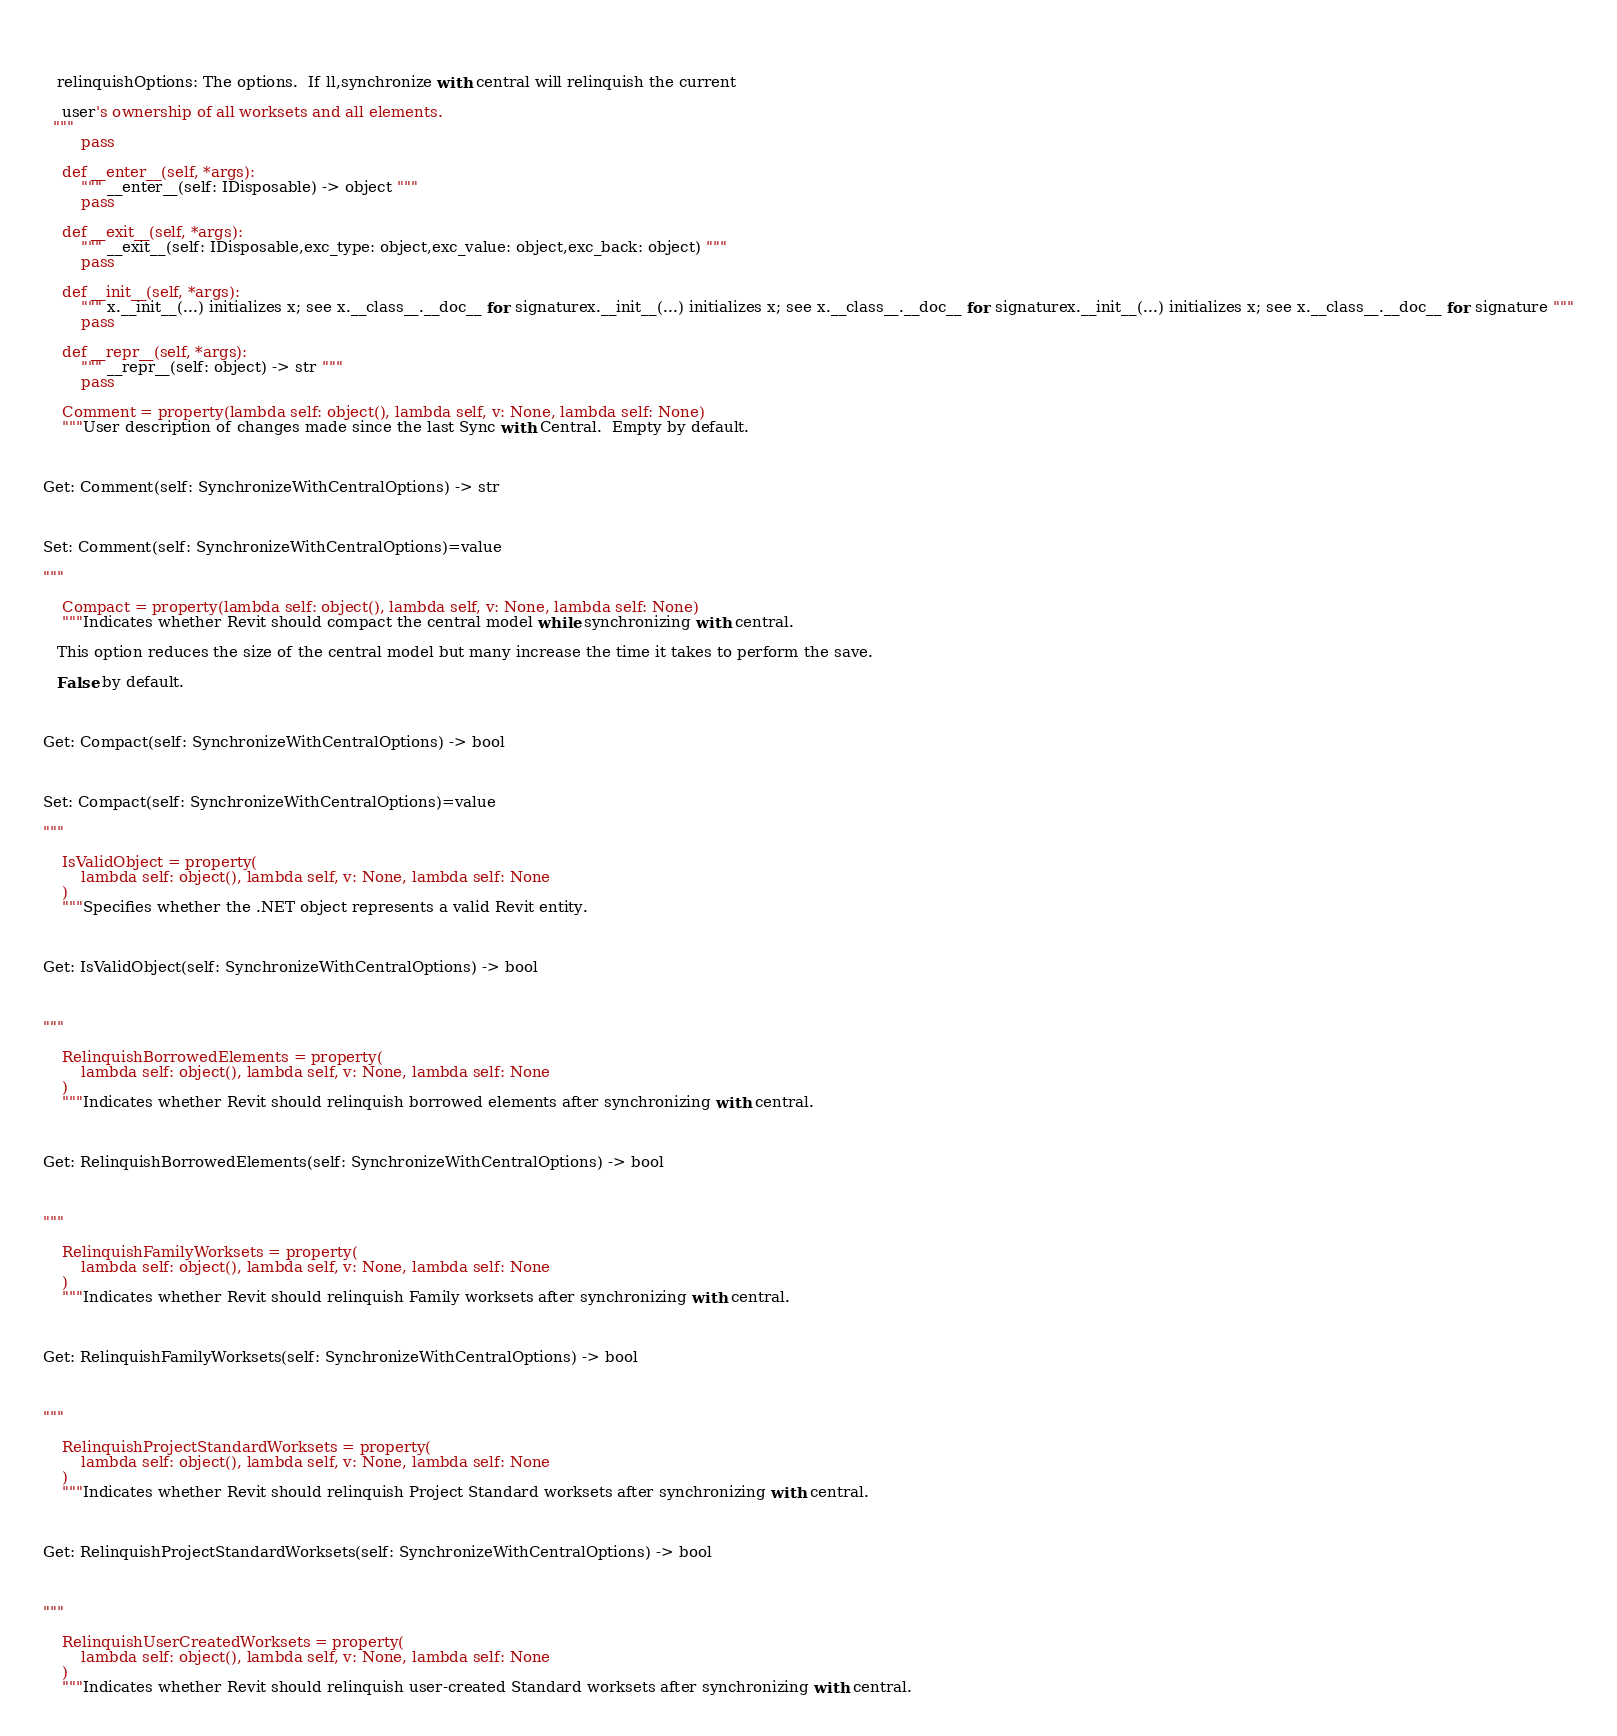Convert code to text. <code><loc_0><loc_0><loc_500><loc_500><_Python_>
  

   relinquishOptions: The options.  If ll,synchronize with central will relinquish the current 

    user's ownership of all worksets and all elements.
  """
        pass

    def __enter__(self, *args):
        """ __enter__(self: IDisposable) -> object """
        pass

    def __exit__(self, *args):
        """ __exit__(self: IDisposable,exc_type: object,exc_value: object,exc_back: object) """
        pass

    def __init__(self, *args):
        """ x.__init__(...) initializes x; see x.__class__.__doc__ for signaturex.__init__(...) initializes x; see x.__class__.__doc__ for signaturex.__init__(...) initializes x; see x.__class__.__doc__ for signature """
        pass

    def __repr__(self, *args):
        """ __repr__(self: object) -> str """
        pass

    Comment = property(lambda self: object(), lambda self, v: None, lambda self: None)
    """User description of changes made since the last Sync with Central.  Empty by default.



Get: Comment(self: SynchronizeWithCentralOptions) -> str



Set: Comment(self: SynchronizeWithCentralOptions)=value

"""

    Compact = property(lambda self: object(), lambda self, v: None, lambda self: None)
    """Indicates whether Revit should compact the central model while synchronizing with central.

   This option reduces the size of the central model but many increase the time it takes to perform the save.

   False by default.



Get: Compact(self: SynchronizeWithCentralOptions) -> bool



Set: Compact(self: SynchronizeWithCentralOptions)=value

"""

    IsValidObject = property(
        lambda self: object(), lambda self, v: None, lambda self: None
    )
    """Specifies whether the .NET object represents a valid Revit entity.



Get: IsValidObject(self: SynchronizeWithCentralOptions) -> bool



"""

    RelinquishBorrowedElements = property(
        lambda self: object(), lambda self, v: None, lambda self: None
    )
    """Indicates whether Revit should relinquish borrowed elements after synchronizing with central.



Get: RelinquishBorrowedElements(self: SynchronizeWithCentralOptions) -> bool



"""

    RelinquishFamilyWorksets = property(
        lambda self: object(), lambda self, v: None, lambda self: None
    )
    """Indicates whether Revit should relinquish Family worksets after synchronizing with central.



Get: RelinquishFamilyWorksets(self: SynchronizeWithCentralOptions) -> bool



"""

    RelinquishProjectStandardWorksets = property(
        lambda self: object(), lambda self, v: None, lambda self: None
    )
    """Indicates whether Revit should relinquish Project Standard worksets after synchronizing with central.



Get: RelinquishProjectStandardWorksets(self: SynchronizeWithCentralOptions) -> bool



"""

    RelinquishUserCreatedWorksets = property(
        lambda self: object(), lambda self, v: None, lambda self: None
    )
    """Indicates whether Revit should relinquish user-created Standard worksets after synchronizing with central.


</code> 